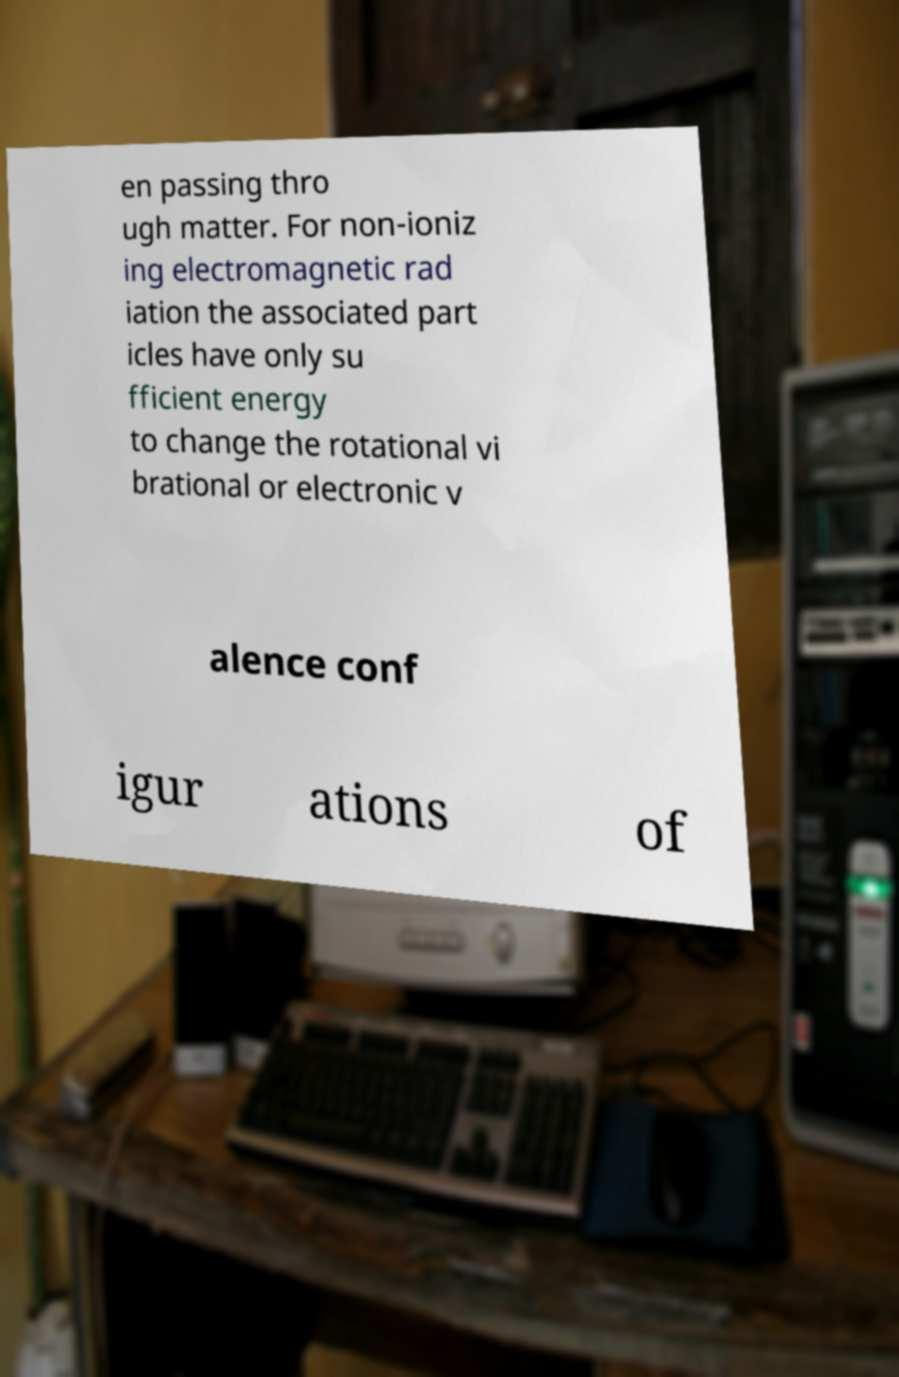Could you assist in decoding the text presented in this image and type it out clearly? en passing thro ugh matter. For non-ioniz ing electromagnetic rad iation the associated part icles have only su fficient energy to change the rotational vi brational or electronic v alence conf igur ations of 